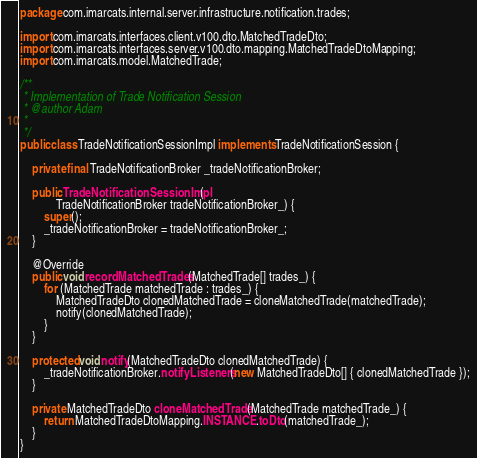<code> <loc_0><loc_0><loc_500><loc_500><_Java_>package com.imarcats.internal.server.infrastructure.notification.trades;

import com.imarcats.interfaces.client.v100.dto.MatchedTradeDto;
import com.imarcats.interfaces.server.v100.dto.mapping.MatchedTradeDtoMapping;
import com.imarcats.model.MatchedTrade;

/**
 * Implementation of Trade Notification Session
 * @author Adam
 *
 */
public class TradeNotificationSessionImpl implements TradeNotificationSession {

	private final TradeNotificationBroker _tradeNotificationBroker;
	
	public TradeNotificationSessionImpl(
			TradeNotificationBroker tradeNotificationBroker_) {
		super();
		_tradeNotificationBroker = tradeNotificationBroker_;
	}

	@Override
	public void recordMatchedTrades(MatchedTrade[] trades_) {
		for (MatchedTrade matchedTrade : trades_) {
			MatchedTradeDto clonedMatchedTrade = cloneMatchedTrade(matchedTrade);
			notify(clonedMatchedTrade);
		}
	}

	protected void notify(MatchedTradeDto clonedMatchedTrade) {
		_tradeNotificationBroker.notifyListeners(new MatchedTradeDto[] { clonedMatchedTrade });
	}

	private MatchedTradeDto cloneMatchedTrade(MatchedTrade matchedTrade_) {
		return MatchedTradeDtoMapping.INSTANCE.toDto(matchedTrade_); 
	}
}
</code> 